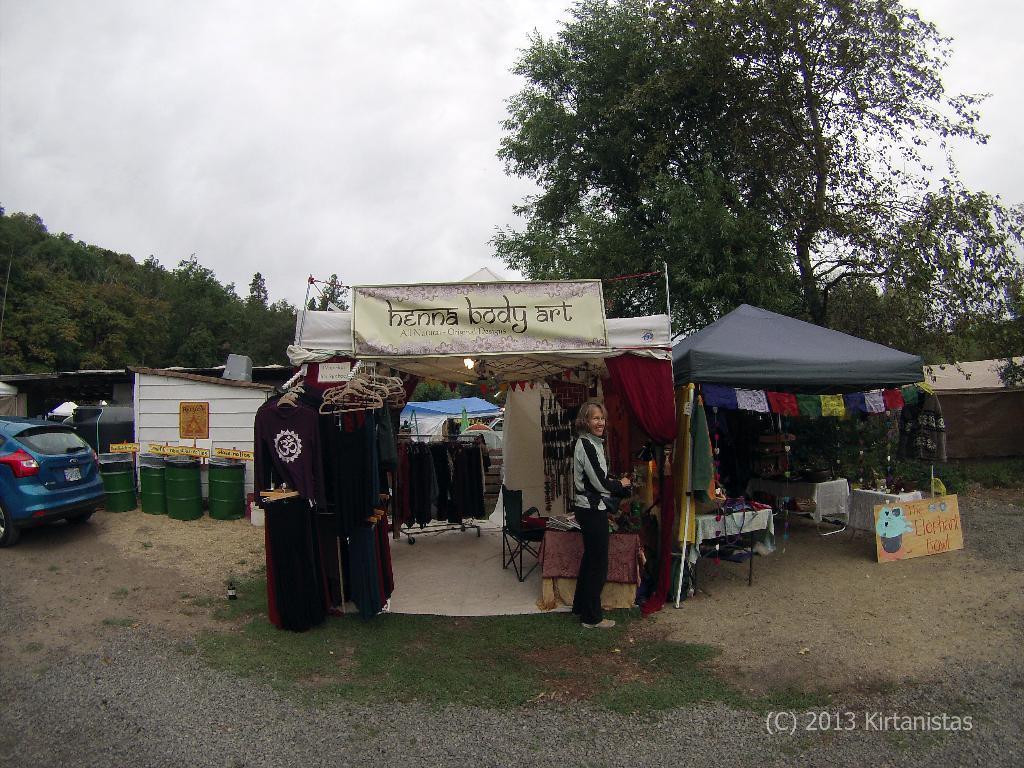Please provide a concise description of this image. There is a woman standing and we can see stalls, tents, clothes and banner. We can see grass, barrels, boards, car and shed. In the background we can see trees and sky. In the bottom right side of the image we can see text. 